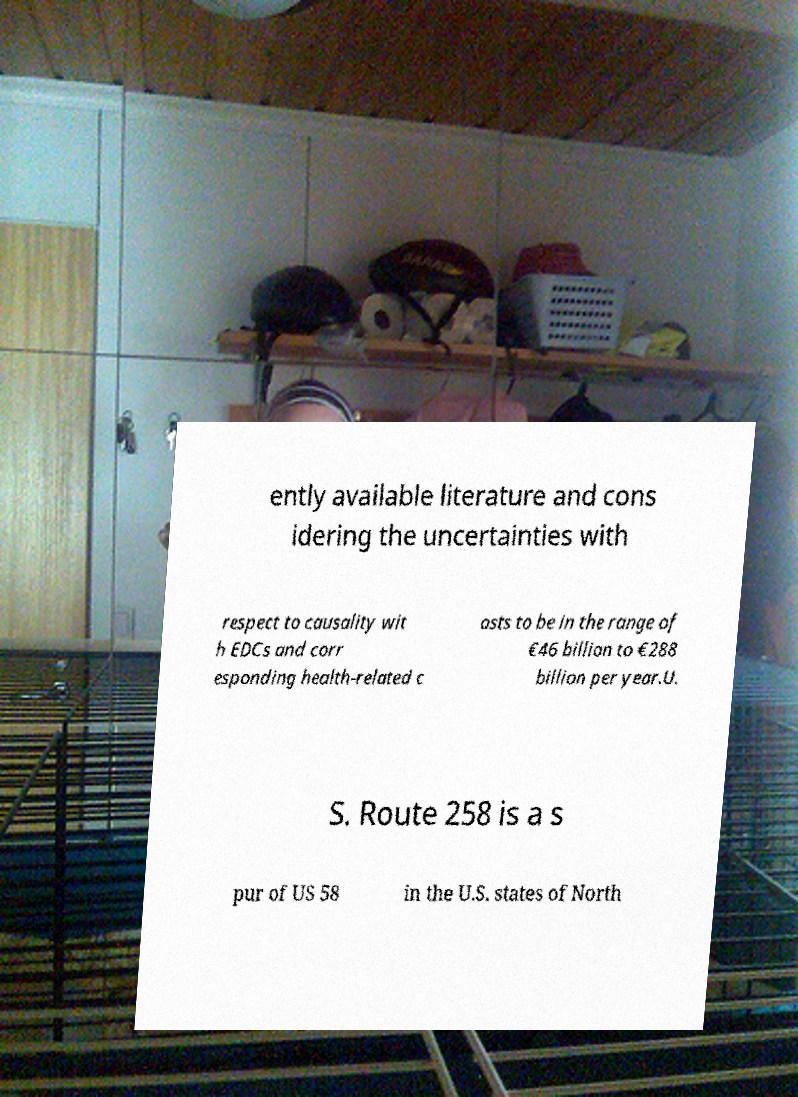Could you assist in decoding the text presented in this image and type it out clearly? ently available literature and cons idering the uncertainties with respect to causality wit h EDCs and corr esponding health-related c osts to be in the range of €46 billion to €288 billion per year.U. S. Route 258 is a s pur of US 58 in the U.S. states of North 